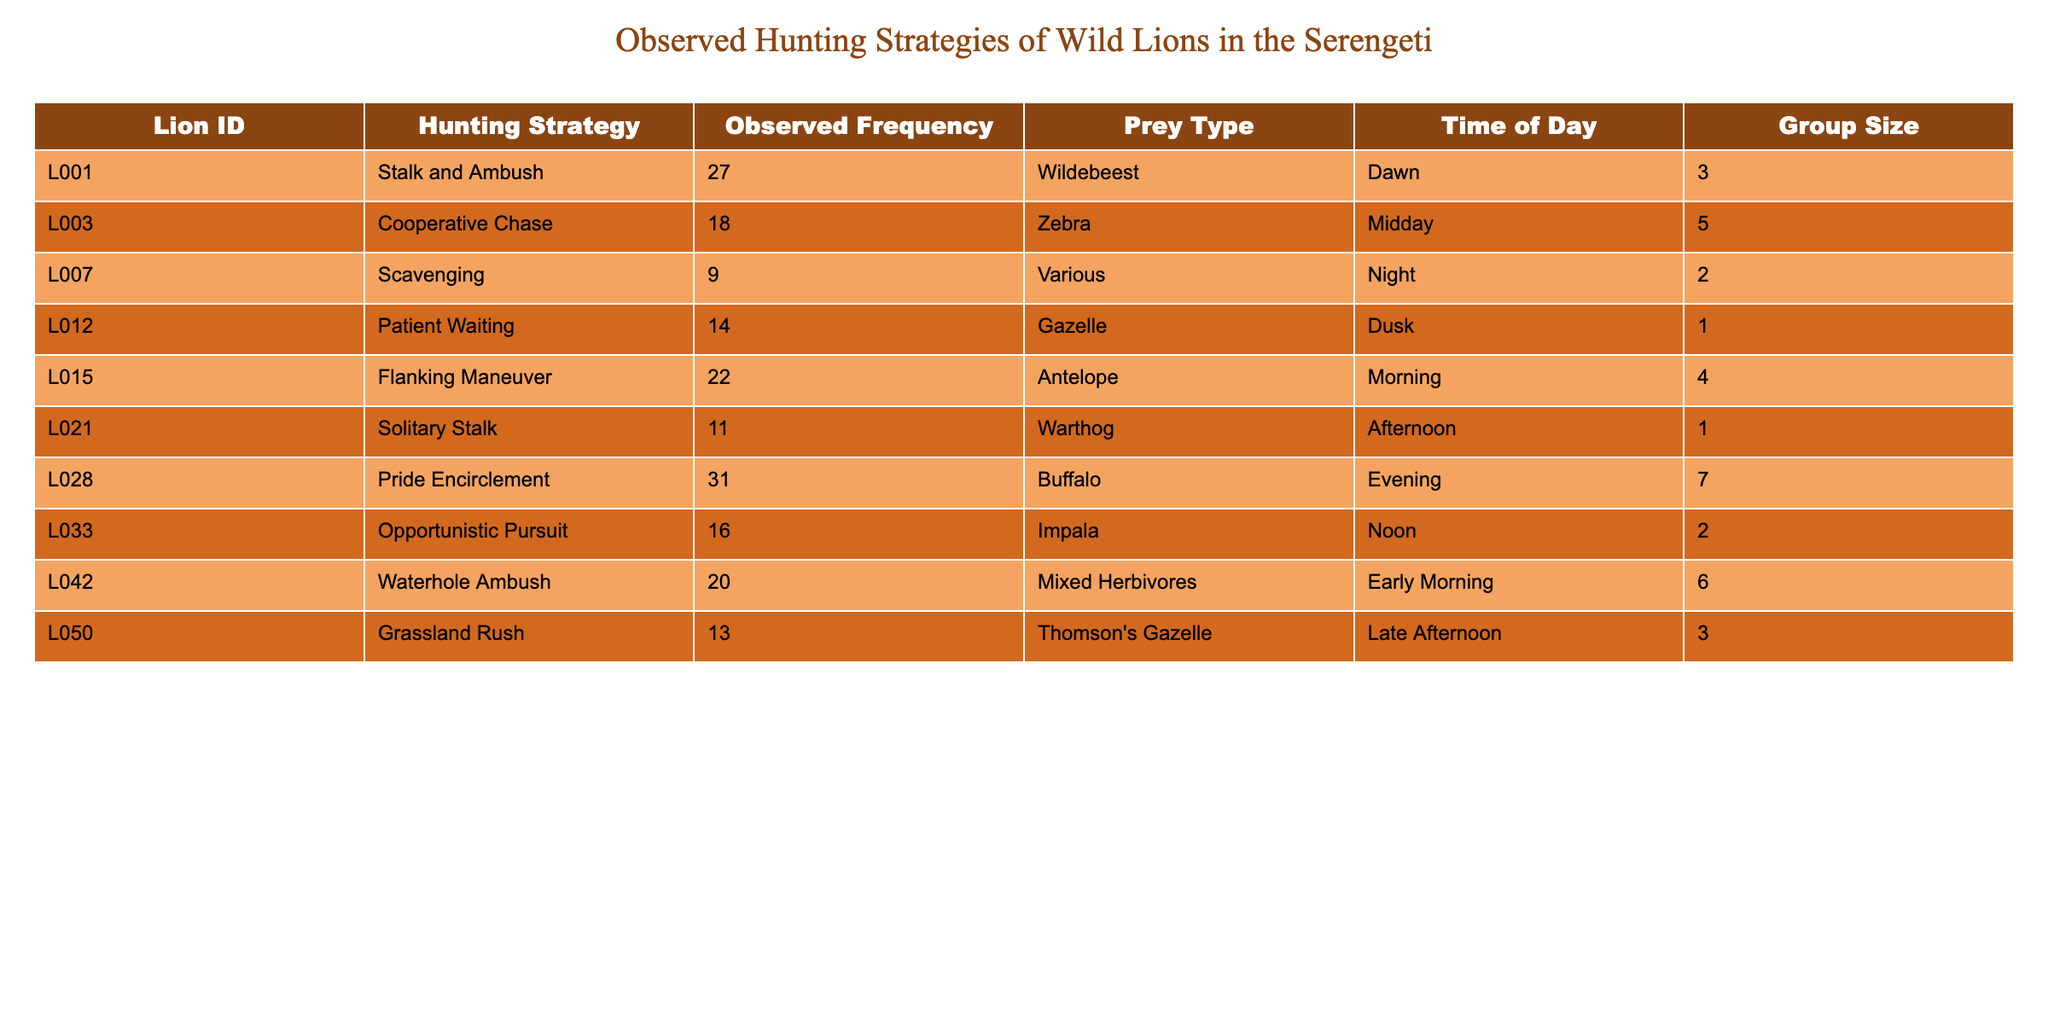What is the most frequently observed hunting strategy? The hunting strategy with the highest observed frequency is listed in the "Observed Frequency" column. The maximum value is 31, which corresponds to the "Pride Encirclement" strategy.
Answer: Pride Encirclement How many lions were observed using the "Stalk and Ambush" strategy? The "Stalk and Ambush" strategy is associated with Lion ID L001, and the observed frequency for this strategy is 27 according to the table.
Answer: 27 What is the average group size for the hunting strategies observed? First, we sum the group sizes: 3 + 5 + 2 + 1 + 4 + 1 + 7 + 2 + 6 + 3 = 34. There are 10 observations, so we divide 34 by 10, giving us an average group size of 3.4.
Answer: 3.4 Is "Scavenging" a more frequently observed hunting strategy than "Patient Waiting"? We compare the observed frequencies: "Scavenging" has an observed frequency of 9, and "Patient Waiting" has 14. Since 9 is less than 14, "Scavenging" is not more frequent.
Answer: No Which hunting strategy has the highest observed frequency during the evening? The table shows that "Pride Encirclement" is the only hunting strategy listed for the evening and has a frequency of 31. Therefore, it has the highest observed frequency for that time.
Answer: Pride Encirclement What is the total observed frequency of all scavenging behaviors? The table lists only one hunting strategy, "Scavenging," with a frequency of 9. Therefore, the total observed frequency for scavenging behaviors is simply 9.
Answer: 9 How does the frequency of "Cooperative Chase" compare to that of "Flanking Maneuver"? The observed frequency for "Cooperative Chase" is 18 and for "Flanking Maneuver" it is 22. Since 18 is less than 22, "Cooperative Chase" occurs less frequently.
Answer: Less frequently What is the group size for the hunting strategies observed during midday? The only hunting strategy observed during midday is "Cooperative Chase," and its group size is 5.
Answer: 5 Which hunting strategy involves the most lions based on group size? "Pride Encirclement" involves 7 lions, which is the highest group size among the strategies listed in the table.
Answer: 7 Are there any strategies that were observed at night? The table shows that "Scavenging" is the only strategy observed at night, confirming that there is at least one such strategy.
Answer: Yes 